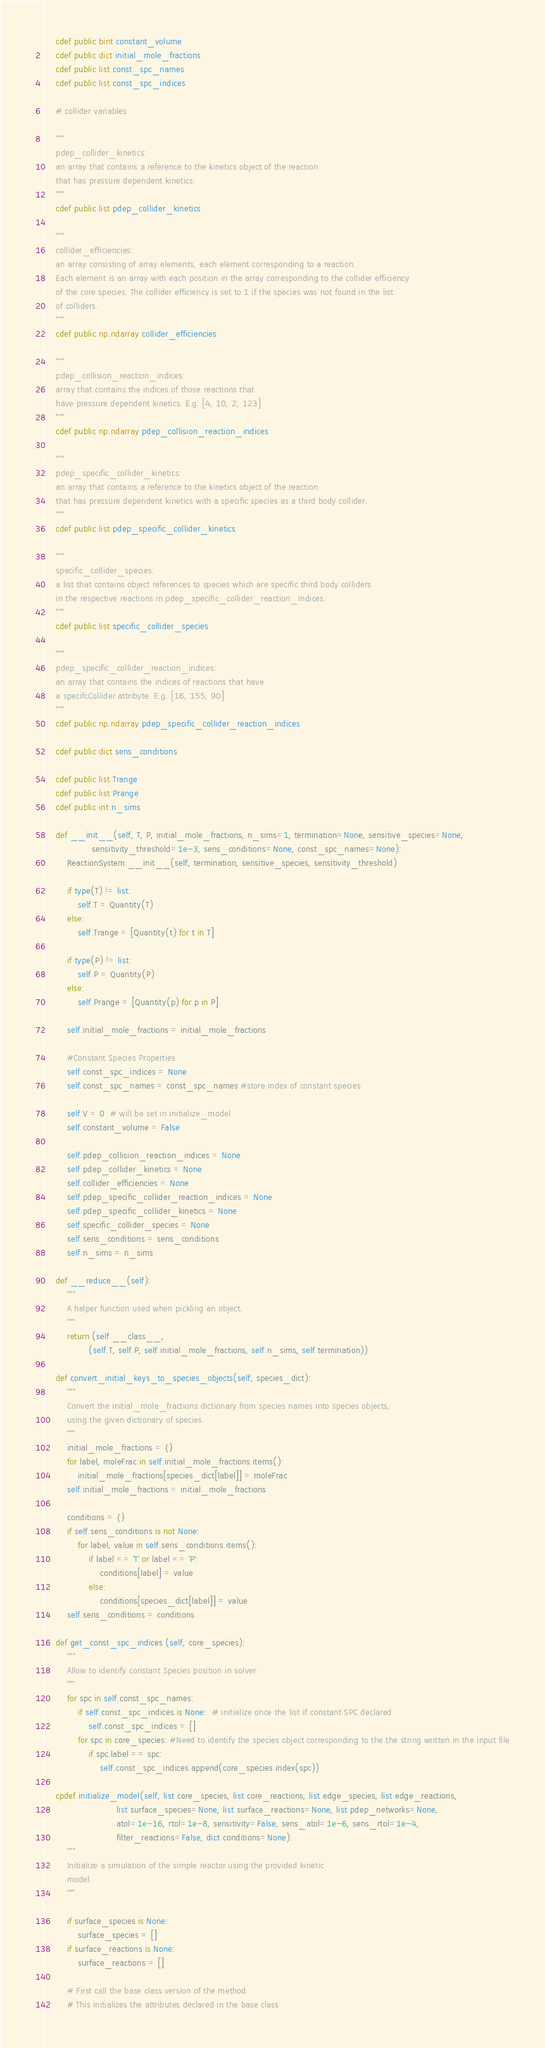<code> <loc_0><loc_0><loc_500><loc_500><_Cython_>    cdef public bint constant_volume
    cdef public dict initial_mole_fractions
    cdef public list const_spc_names 
    cdef public list const_spc_indices

    # collider variables

    """
    pdep_collider_kinetics:
    an array that contains a reference to the kinetics object of the reaction
    that has pressure dependent kinetics.
    """
    cdef public list pdep_collider_kinetics

    """
    collider_efficiencies:
    an array consisting of array elements, each element corresponding to a reaction.
    Each element is an array with each position in the array corresponding to the collider efficiency
    of the core species. The collider efficiency is set to 1 if the species was not found in the list
    of colliders.
    """
    cdef public np.ndarray collider_efficiencies

    """
    pdep_collision_reaction_indices: 
    array that contains the indices of those reactions that 
    have pressure dependent kinetics. E.g. [4, 10, 2, 123]
    """
    cdef public np.ndarray pdep_collision_reaction_indices

    """
    pdep_specific_collider_kinetics:
    an array that contains a reference to the kinetics object of the reaction
    that has pressure dependent kinetics with a specific species as a third body collider.
    """
    cdef public list pdep_specific_collider_kinetics

    """
    specific_collider_species:
    a list that contains object references to species which are specific third body colliders
    in the respective reactions in pdep_specific_collider_reaction_indices.
    """
    cdef public list specific_collider_species

    """
    pdep_specific_collider_reaction_indices:
    an array that contains the indices of reactions that have
    a specifcCollider attribyte. E.g. [16, 155, 90]
    """
    cdef public np.ndarray pdep_specific_collider_reaction_indices

    cdef public dict sens_conditions

    cdef public list Trange
    cdef public list Prange
    cdef public int n_sims

    def __init__(self, T, P, initial_mole_fractions, n_sims=1, termination=None, sensitive_species=None,
                 sensitivity_threshold=1e-3, sens_conditions=None, const_spc_names=None):
        ReactionSystem.__init__(self, termination, sensitive_species, sensitivity_threshold)

        if type(T) != list:
            self.T = Quantity(T)
        else:
            self.Trange = [Quantity(t) for t in T]

        if type(P) != list:
            self.P = Quantity(P)
        else:
            self.Prange = [Quantity(p) for p in P]

        self.initial_mole_fractions = initial_mole_fractions

        #Constant Species Properties
        self.const_spc_indices = None
        self.const_spc_names = const_spc_names #store index of constant species 

        self.V = 0  # will be set in initialize_model
        self.constant_volume = False

        self.pdep_collision_reaction_indices = None
        self.pdep_collider_kinetics = None
        self.collider_efficiencies = None
        self.pdep_specific_collider_reaction_indices = None
        self.pdep_specific_collider_kinetics = None
        self.specific_collider_species = None
        self.sens_conditions = sens_conditions
        self.n_sims = n_sims

    def __reduce__(self):
        """
        A helper function used when pickling an object.
        """
        return (self.__class__,
                (self.T, self.P, self.initial_mole_fractions, self.n_sims, self.termination))

    def convert_initial_keys_to_species_objects(self, species_dict):
        """
        Convert the initial_mole_fractions dictionary from species names into species objects,
        using the given dictionary of species.
        """
        initial_mole_fractions = {}
        for label, moleFrac in self.initial_mole_fractions.items():
            initial_mole_fractions[species_dict[label]] = moleFrac
        self.initial_mole_fractions = initial_mole_fractions

        conditions = {}
        if self.sens_conditions is not None:
            for label, value in self.sens_conditions.items():
                if label == 'T' or label == 'P':
                    conditions[label] = value
                else:
                    conditions[species_dict[label]] = value
        self.sens_conditions = conditions

    def get_const_spc_indices (self, core_species):
        """
        Allow to identify constant Species position in solver
        """
        for spc in self.const_spc_names:
            if self.const_spc_indices is None:  # initialize once the list if constant SPC declared
                self.const_spc_indices = []
            for spc in core_species: #Need to identify the species object corresponding to the the string written in the input file
                if spc.label == spc:
                    self.const_spc_indices.append(core_species.index(spc)) 

    cpdef initialize_model(self, list core_species, list core_reactions, list edge_species, list edge_reactions,
                          list surface_species=None, list surface_reactions=None, list pdep_networks=None,
                          atol=1e-16, rtol=1e-8, sensitivity=False, sens_atol=1e-6, sens_rtol=1e-4,
                          filter_reactions=False, dict conditions=None):
        """
        Initialize a simulation of the simple reactor using the provided kinetic
        model.
        """

        if surface_species is None:
            surface_species = []
        if surface_reactions is None:
            surface_reactions = []

        # First call the base class version of the method
        # This initializes the attributes declared in the base class</code> 